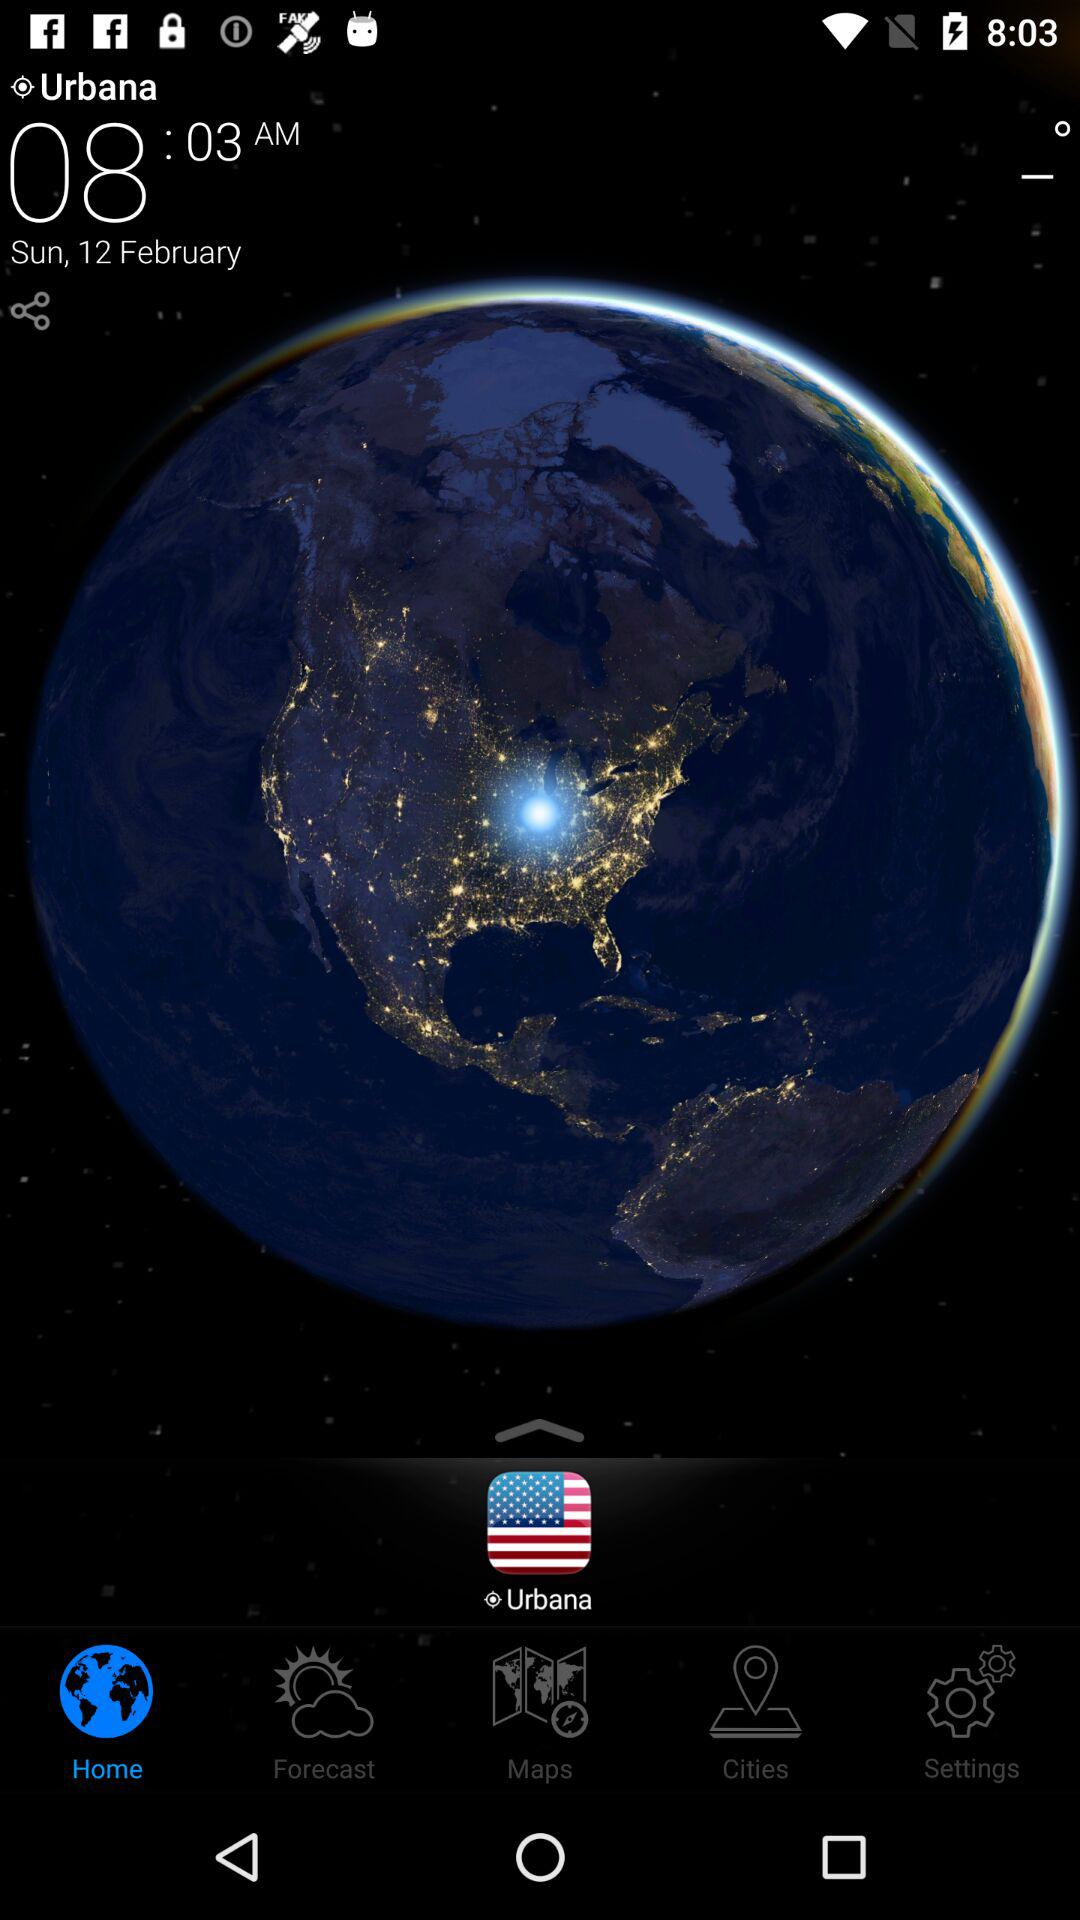What is the city name? The city name is Urbana. 